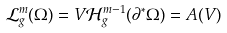<formula> <loc_0><loc_0><loc_500><loc_500>\mathcal { L } ^ { m } _ { g } ( \Omega ) = V \mathcal { H } ^ { m - 1 } _ { g } ( \partial ^ { * } \Omega ) = A ( V )</formula> 